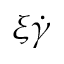<formula> <loc_0><loc_0><loc_500><loc_500>\xi \dot { \gamma }</formula> 